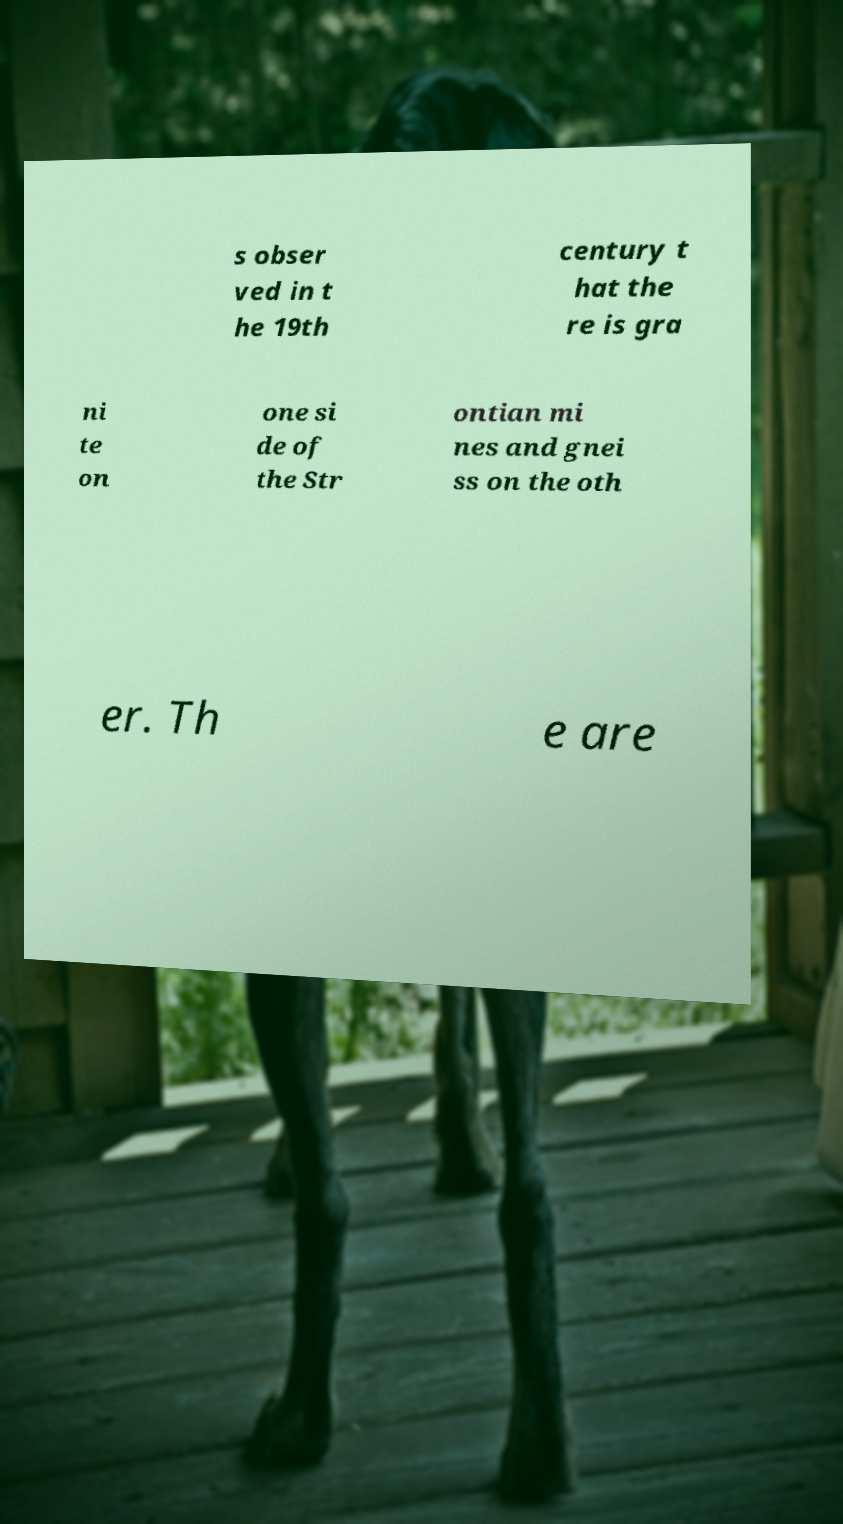Please read and relay the text visible in this image. What does it say? s obser ved in t he 19th century t hat the re is gra ni te on one si de of the Str ontian mi nes and gnei ss on the oth er. Th e are 